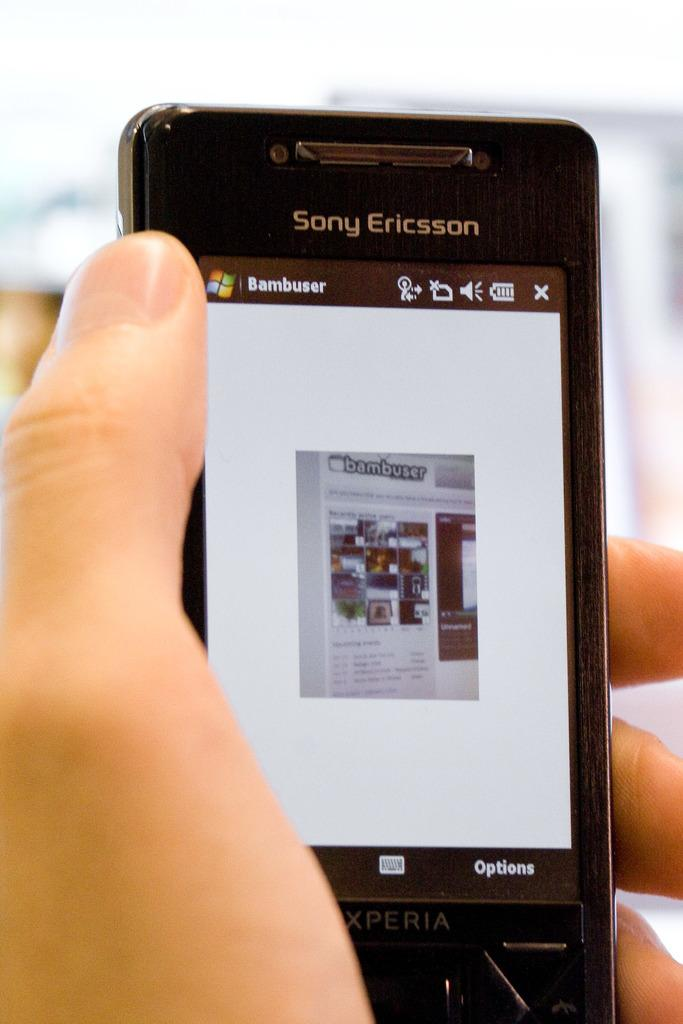<image>
Write a terse but informative summary of the picture. A Sony Ericsson phone being held up with a hand 